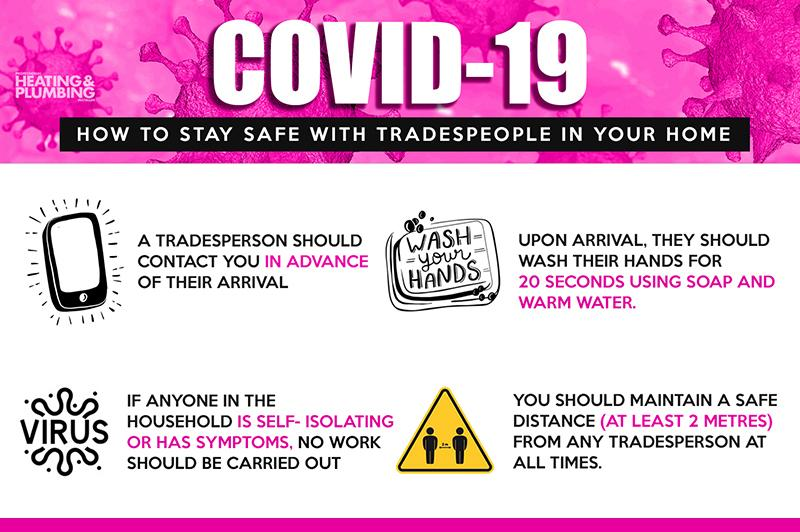Indicate a few pertinent items in this graphic. The number of persons depicted inside the triangle image is two. The background color of the triangle is yellow. It is necessary for the shopkeeper to contact the delivery destination in advance before reaching the delivery destination in order to follow the proper procedure. The recommended procedure for cleaning the hands is to use soap and warm water for 20 seconds to effectively remove dirt and germs. 